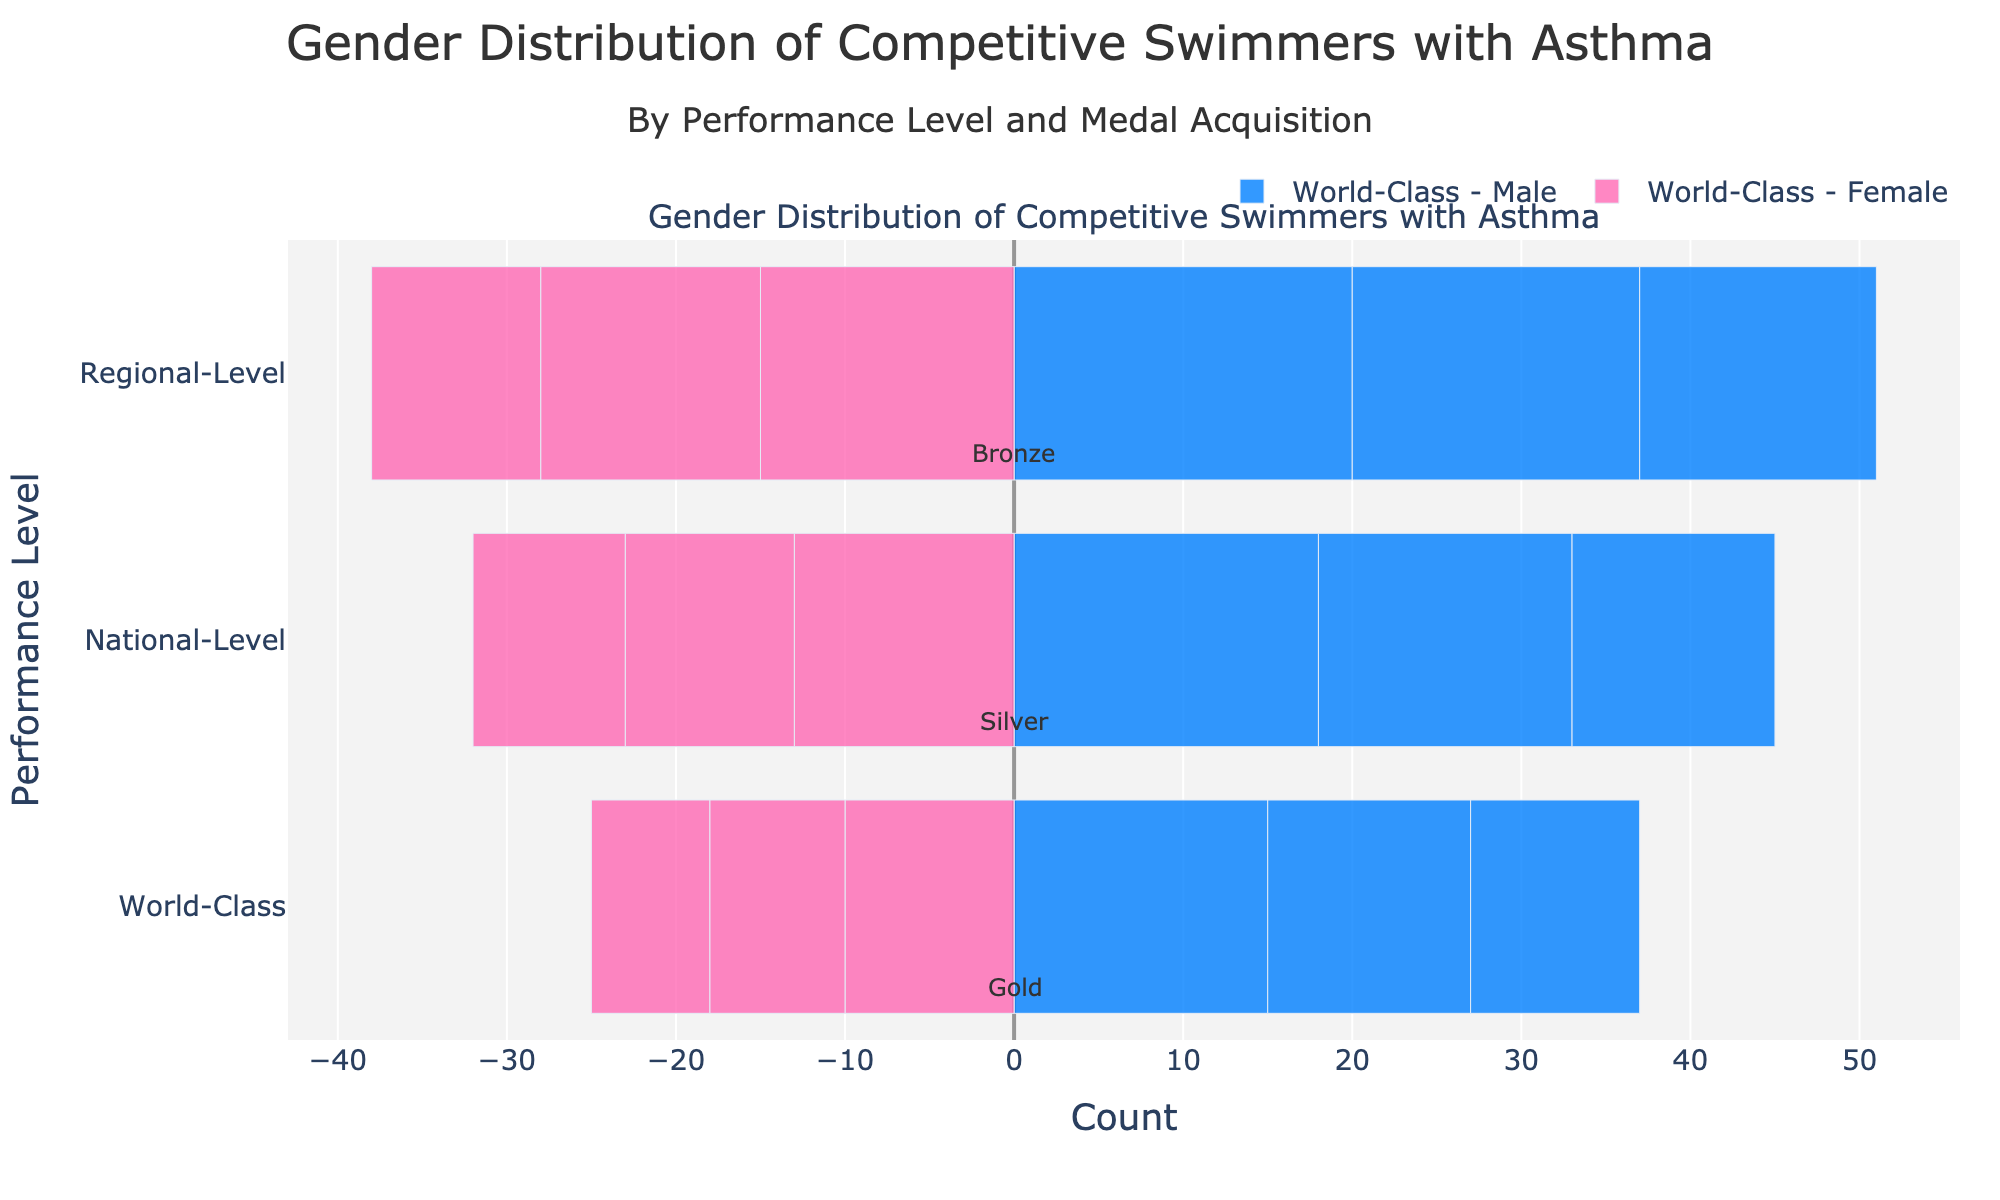Which gender has more representation at the World-Class performance level? At the World-Class performance level, sum up the counts for male (15+12+10=37) and female (10+8+7=25). Males (37) are more represented than females (25).
Answer: Males Which medal type has the highest number of female swimmers with asthma at the Regional-Level performance? At the Regional-Level performance, compare the negative counts for each medal type: Gold (-15), Silver (-13), and Bronze (-10). Gold has the highest absolute number of negative count, indicating the highest number of female swimmers.
Answer: Gold How does the number of male National-Level silver medalists compare to female National-Level bronze medalists? Compare the counts directly: male National-Level silver (15) and female National-Level bronze (9). 15 is greater than 9.
Answer: Male silver medalists are more What is the total number of gold medalists with asthma at the National-Level performance across both genders? Sum the counts for male and female gold medalists at National-Level: male (18) and female (13). 18 + 13 = 31.
Answer: 31 Which gender dominates the bronze medal category at the World-Class level? Compare the counts for male (10) and female (-7) bronze medalists at the World-Class level. 10 is greater than 7 indicating males dominate.
Answer: Males What is the difference in count between male and female Regional-Level silver medalists? Subtract the female Regional-Level silver medalist count (-13) from the male count (17). 17 - 13 = 4.
Answer: 4 Is the number of female swimmers with asthma higher at the World-Class silver medalists level or Regional-Level gold medalists level? Compare the negative counts for World-Class silver (-8) and Regional-Level gold (-15). -15 (absolute value) is higher than -8, indicating more female Regional-Level gold medalists.
Answer: Regional-Level gold How does the range (difference between highest and lowest counts) in male swimmers compare across all performance levels? Determine the highest (20 for Regional-Level gold) and lowest (10 for World-Class bronze) count for male swimmers. 20 - 10 = 10.
Answer: 10 Are there more total silver medalists or bronze medalists with asthma at the National-Level performance for both genders? Sum the counts for National-Level silver (male 15 + female 10 = 25) and National-Level bronze (male 12 + female 9 = 21). 25 is greater than 21.
Answer: Silver What is the cumulative count of female swimmers with asthma across all performance levels and medals? Sum the negative counts for female swimmers: -10 (World-Class Gold) -8 (World-Class Silver) -7 (World-Class Bronze) -13 (National-Level Gold) -10 (National-Level Silver) -9 (National-Level Bronze) -15 (Regional-Level Gold) -13 (Regional-Level Silver) -10 (Regional-Level Bronze). Total = -95.
Answer: 95 